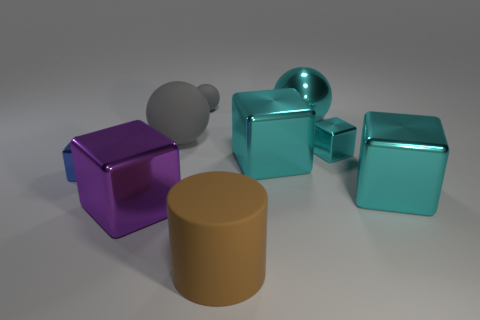Could the arrangement of these objects have any symbolic meaning? The arrangement could represent the diversity and unity—various shapes and sizes coexisting harmoniously—or it could be random, with no intended symbolism. It's an invitation to interpret the scene from one's perspective. 